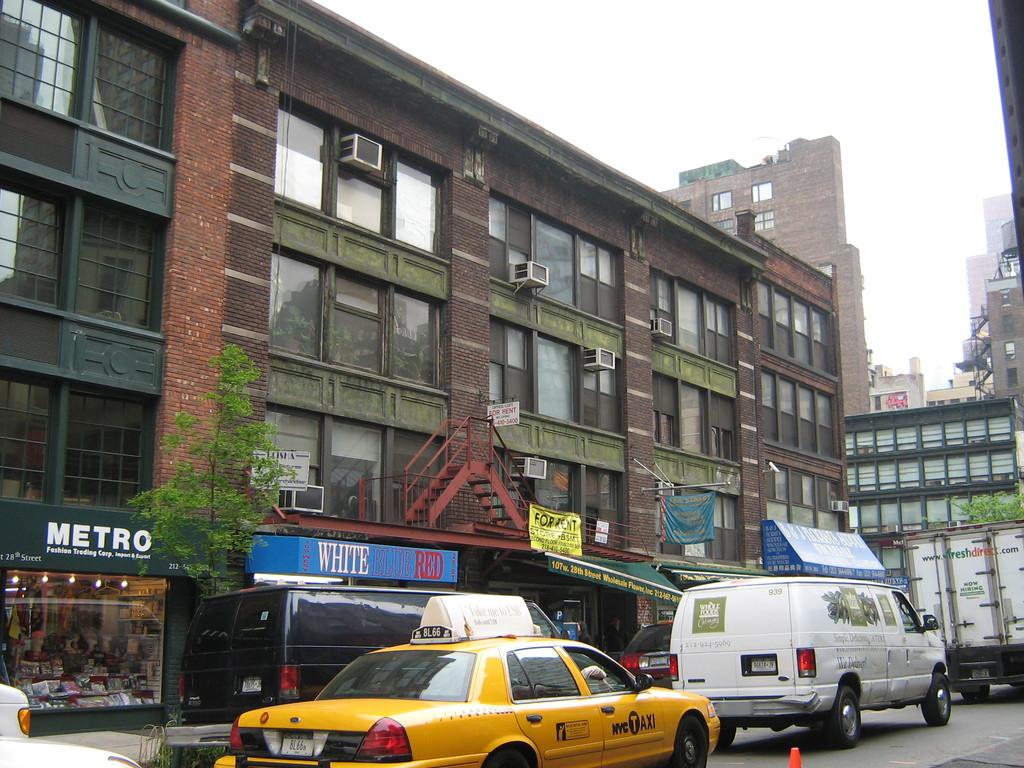Which city is this?
Your answer should be very brief. Nyc. What is the name of the business with the green sign with white font?
Make the answer very short. Metro. 